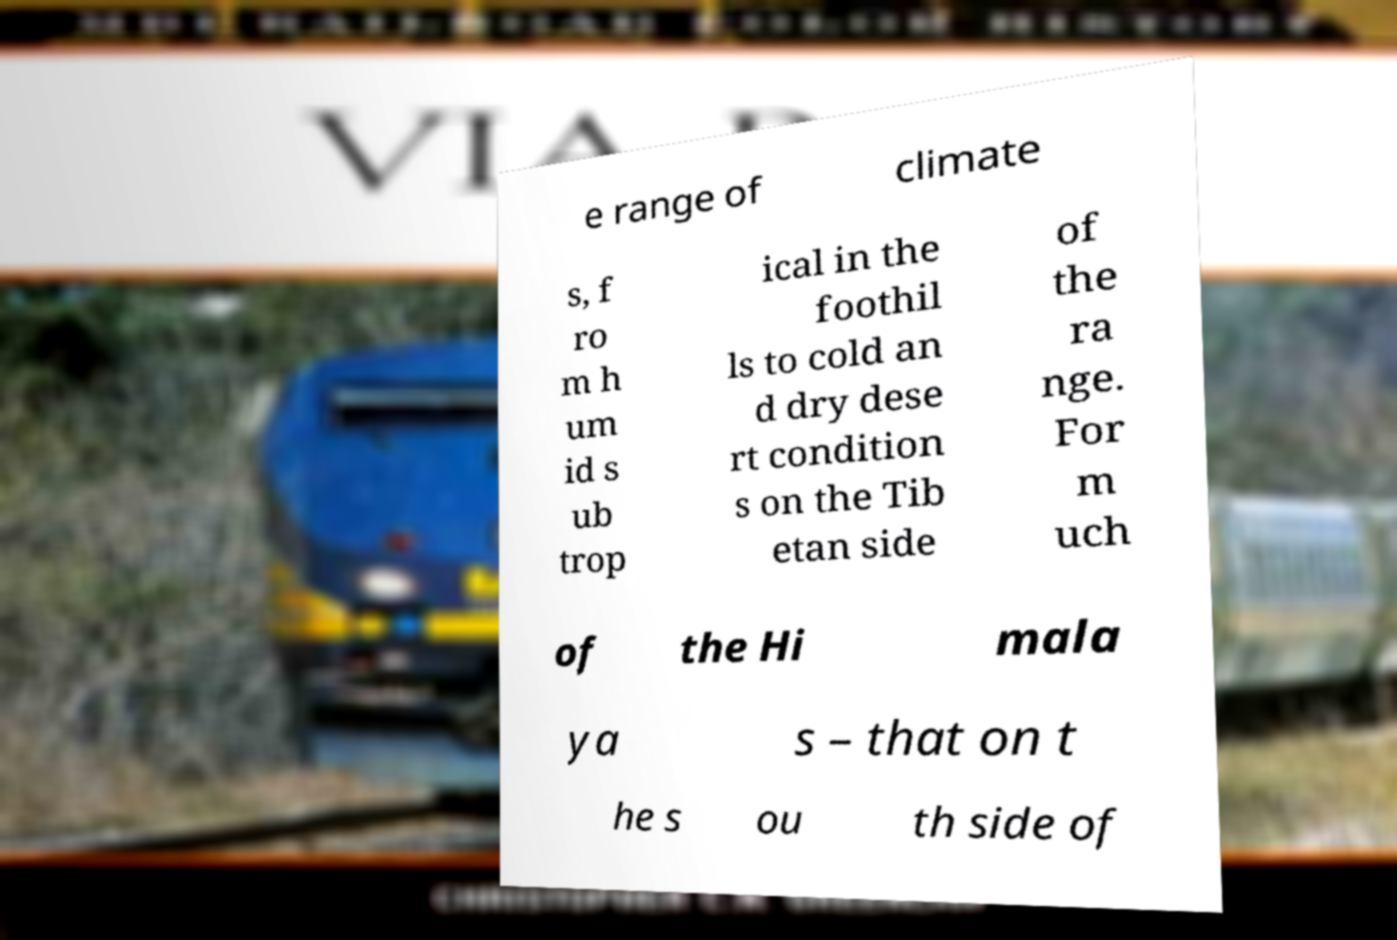Can you read and provide the text displayed in the image?This photo seems to have some interesting text. Can you extract and type it out for me? e range of climate s, f ro m h um id s ub trop ical in the foothil ls to cold an d dry dese rt condition s on the Tib etan side of the ra nge. For m uch of the Hi mala ya s – that on t he s ou th side of 